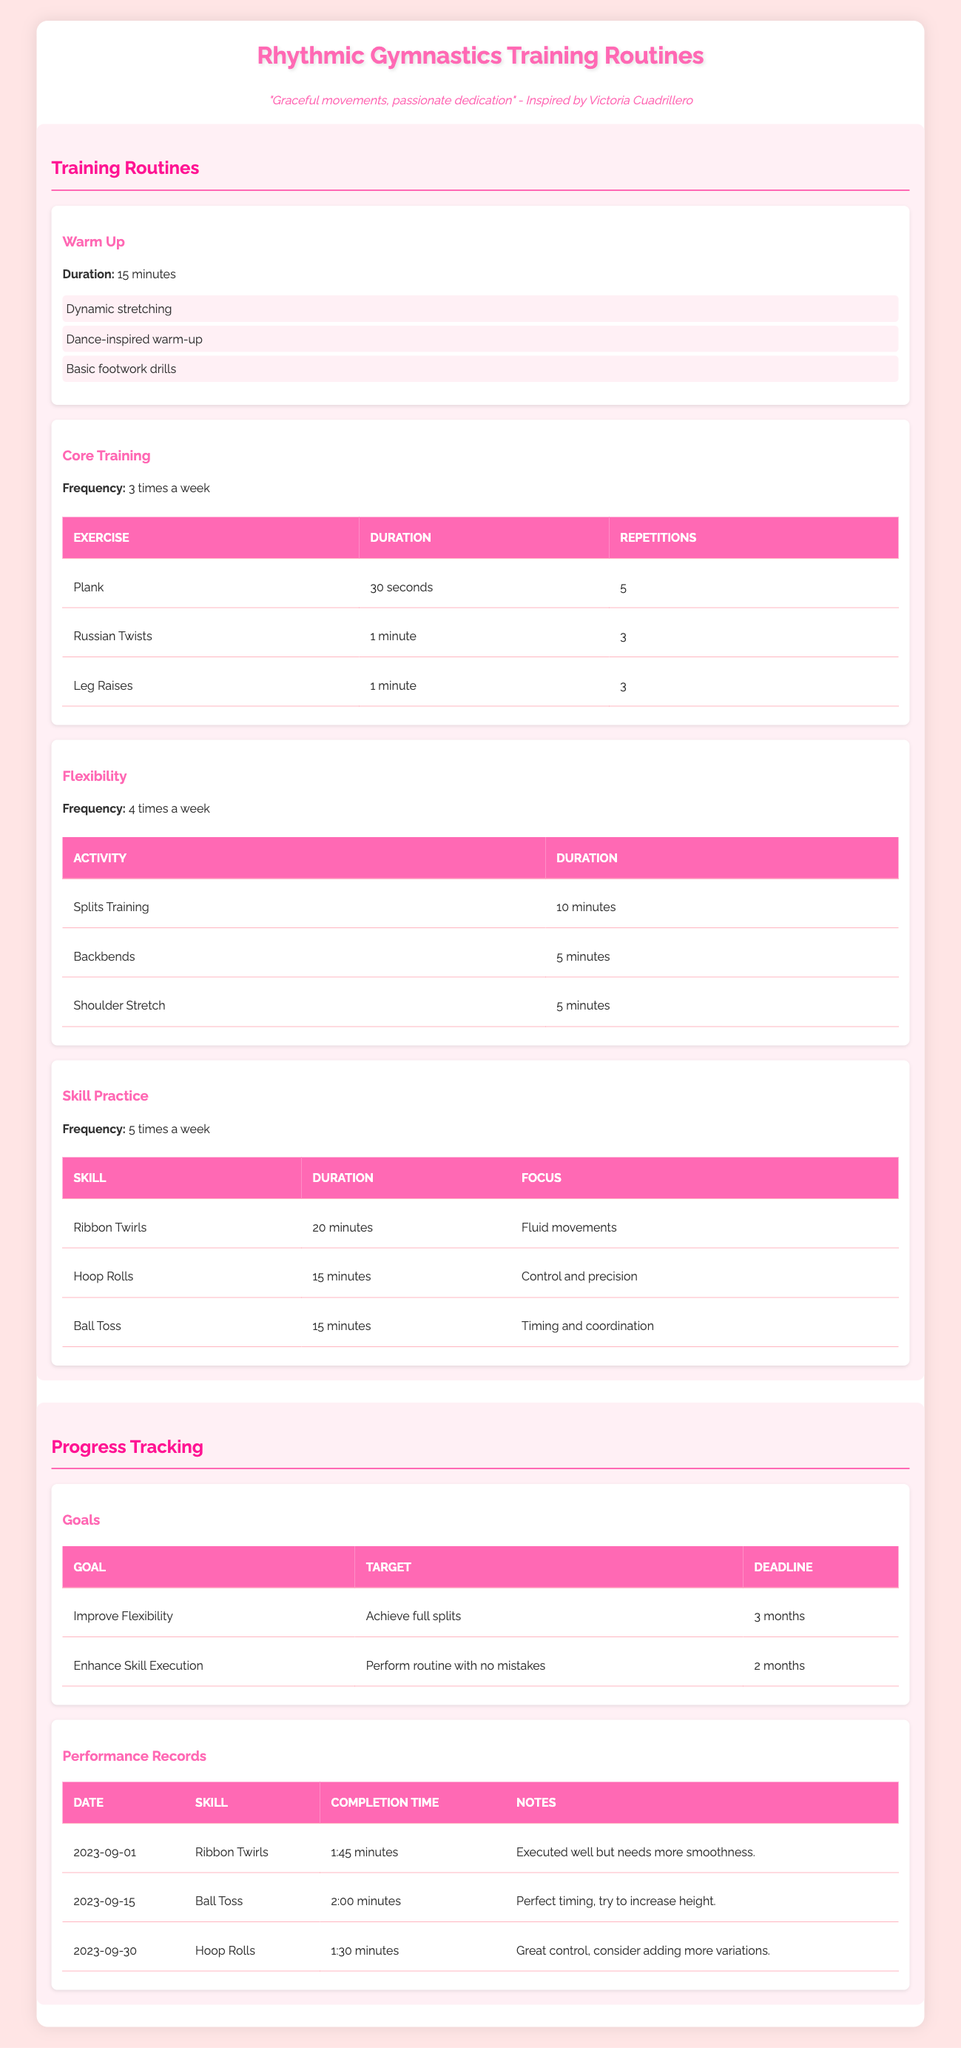What is the duration of the warm-up session? The duration of the warm-up session is listed directly in the table under the "Warm Up" section. It states "Duration: 15 minutes."
Answer: 15 minutes How many times a week is core training recommended? The frequency of core training is explicitly mentioned in the table under the "Core Training" section. It indicates "Frequency: 3 times a week."
Answer: 3 times a week What is the target for the goal "Improve Flexibility"? Looking at the "Goals" section of the table, the target for "Improve Flexibility" is specified as "Achieve full splits."
Answer: Achieve full splits What is the total number of activities listed for flexibility training? The table under the "Flexibility" section shows three activities: Splits Training, Backbends, and Shoulder Stretch. By counting these, we find there are three activities.
Answer: 3 Is it true that "Ball Toss" requires more time to complete than "Ribbon Twirls"? The completion time for "Ball Toss" is 2:00 minutes, while for "Ribbon Twirls," it is 1:45 minutes. Since 2:00 minutes is longer than 1:45 minutes, the statement is true.
Answer: Yes What is the average duration of the skill practice activities? The durations for the skills are 20 minutes for "Ribbon Twirls," 15 minutes for "Hoop Rolls," and 15 minutes for "Ball Toss." To find the average, we add these up: 20 + 15 + 15 = 50 minutes. Divided by the number of activities (3), the average is 50/3 = approximately 16.67 minutes.
Answer: Approximately 16.67 minutes Which skill took the longest time to complete based on the performance records? We look at the "Performance Records" section. "Ball Toss" has a completion time of 2:00 minutes, which is longer than the other skills (1:45 for "Ribbon Twirls" and 1:30 for "Hoop Rolls"). Thus, "Ball Toss" took the longest time.
Answer: Ball Toss How many goals are there listed for progress tracking? In the "Goals" section, there are two entries listed: "Improve Flexibility" and "Enhance Skill Execution." By counting these entries, we find there are two goals.
Answer: 2 